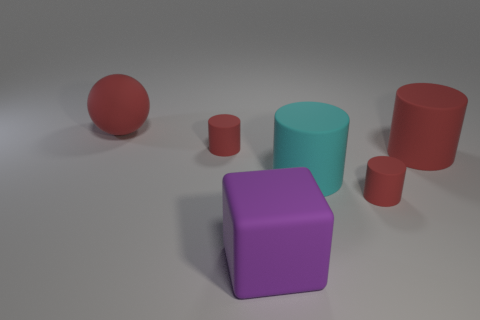Which objects in the image are the most similar in shape? The large red sphere and the smaller red sphere on the right are the most similar in shape, as both are perfect spheres. Are there any cubes in the image? Yes, there is one purple cube in the center of the image. 